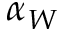<formula> <loc_0><loc_0><loc_500><loc_500>\alpha _ { W }</formula> 